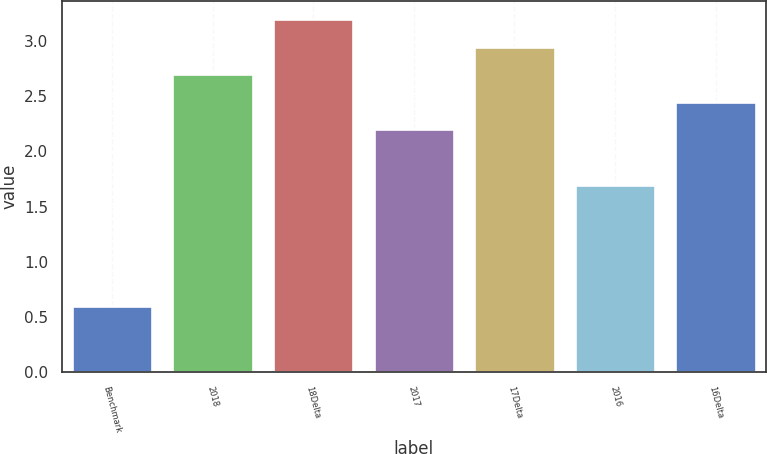<chart> <loc_0><loc_0><loc_500><loc_500><bar_chart><fcel>Benchmark<fcel>2018<fcel>18Delta<fcel>2017<fcel>17Delta<fcel>2016<fcel>16Delta<nl><fcel>0.6<fcel>2.7<fcel>3.2<fcel>2.2<fcel>2.95<fcel>1.7<fcel>2.45<nl></chart> 